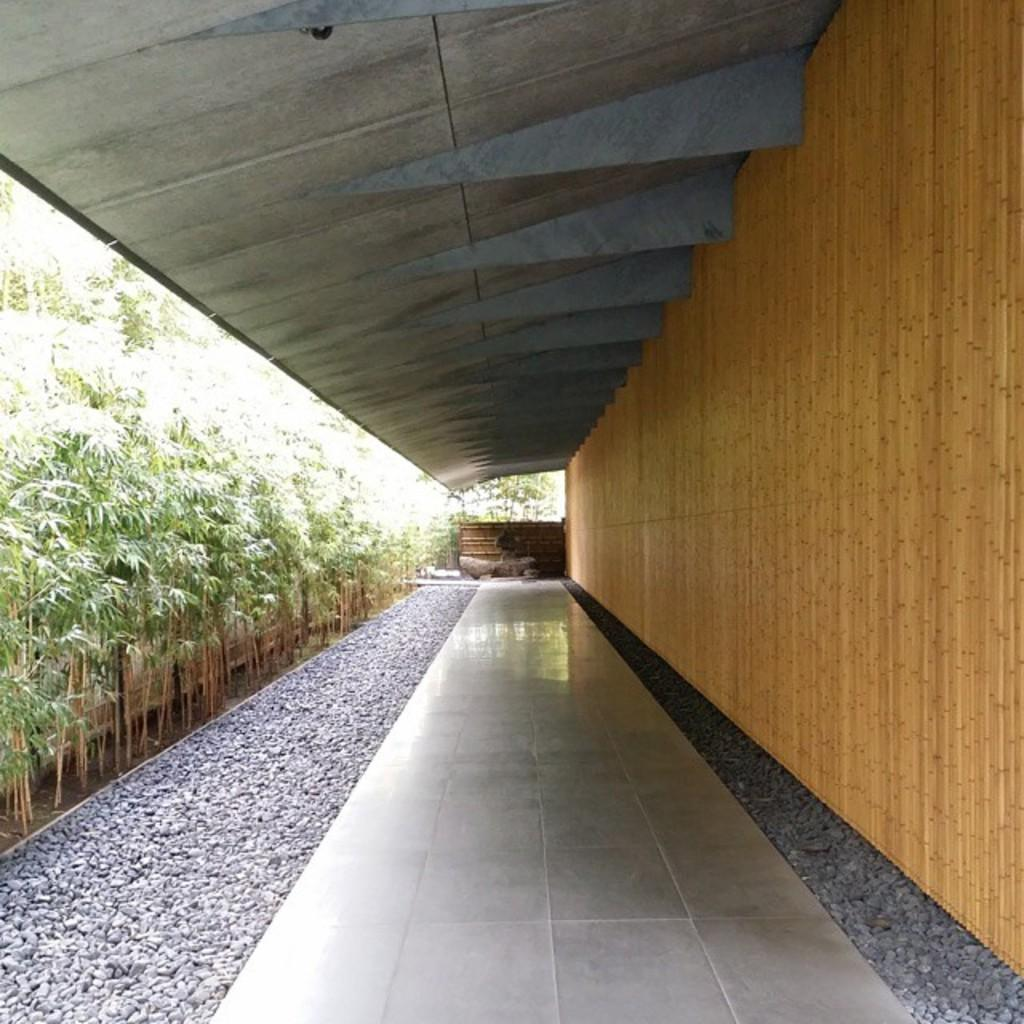What type of flooring is visible in the image? There are white color tiles in the image. What type of natural elements can be seen in the image? There are trees in the image. What religious symbol can be seen in the image? There is no religious symbol present in the image. How many visitors are visible in the scene? There is no scene or visitors present in the image; it only features white color tiles and trees. 